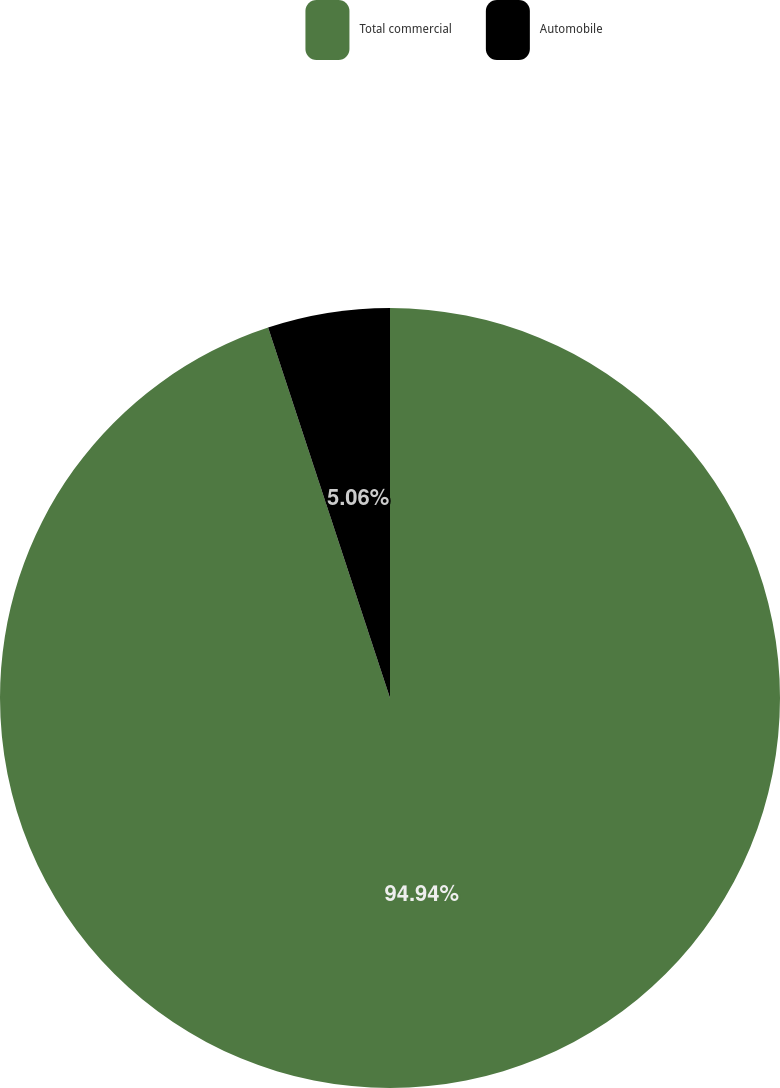Convert chart. <chart><loc_0><loc_0><loc_500><loc_500><pie_chart><fcel>Total commercial<fcel>Automobile<nl><fcel>94.94%<fcel>5.06%<nl></chart> 